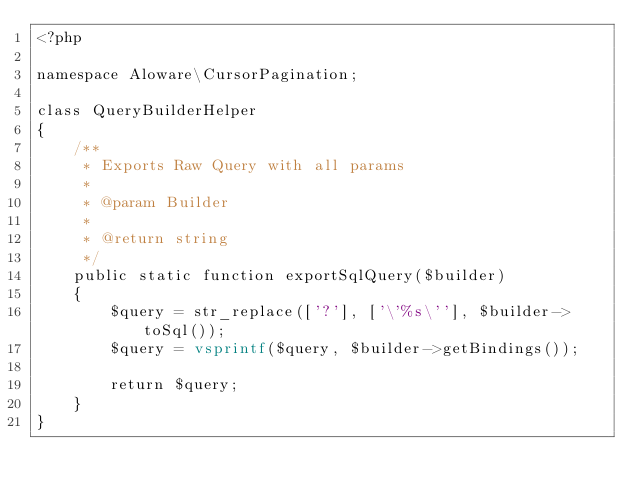<code> <loc_0><loc_0><loc_500><loc_500><_PHP_><?php

namespace Aloware\CursorPagination;

class QueryBuilderHelper
{
    /**
     * Exports Raw Query with all params
     *
     * @param Builder
     *
     * @return string
     */
    public static function exportSqlQuery($builder)
    {
        $query = str_replace(['?'], ['\'%s\''], $builder->toSql());
        $query = vsprintf($query, $builder->getBindings());

        return $query;
    }
}
</code> 